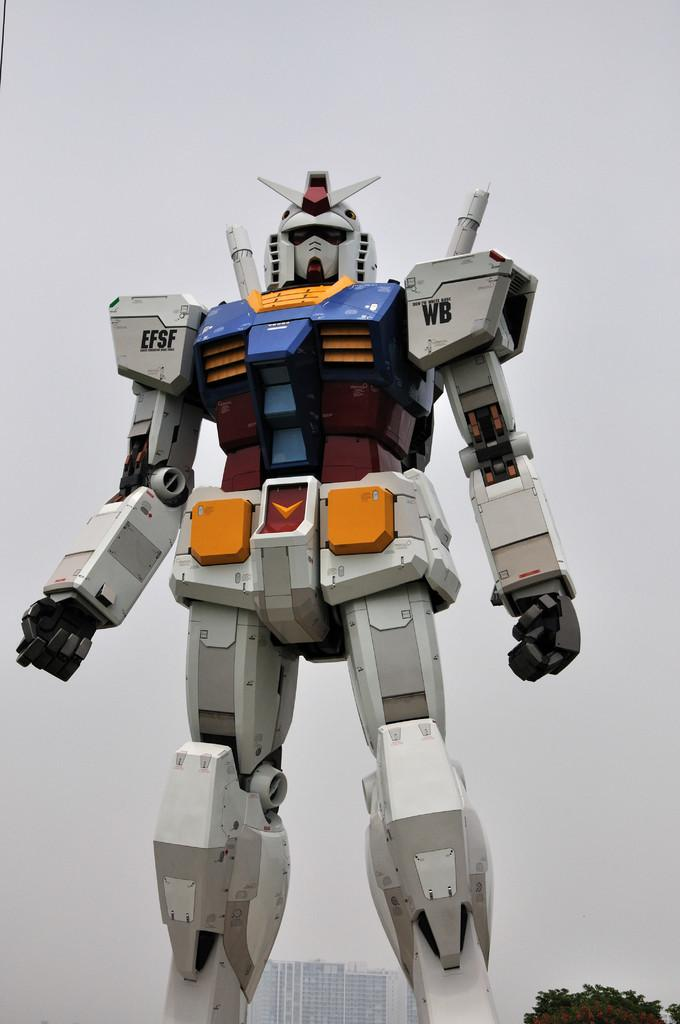What is the main subject of the image? There is a robot in the image. What can be seen in the background of the image? Trees and buildings are visible in the background of the image. What is the color of the background in the image? The background color is white. What type of scene is being adjusted in the image? There is no scene being adjusted in the image; it features a robot with a white background. 